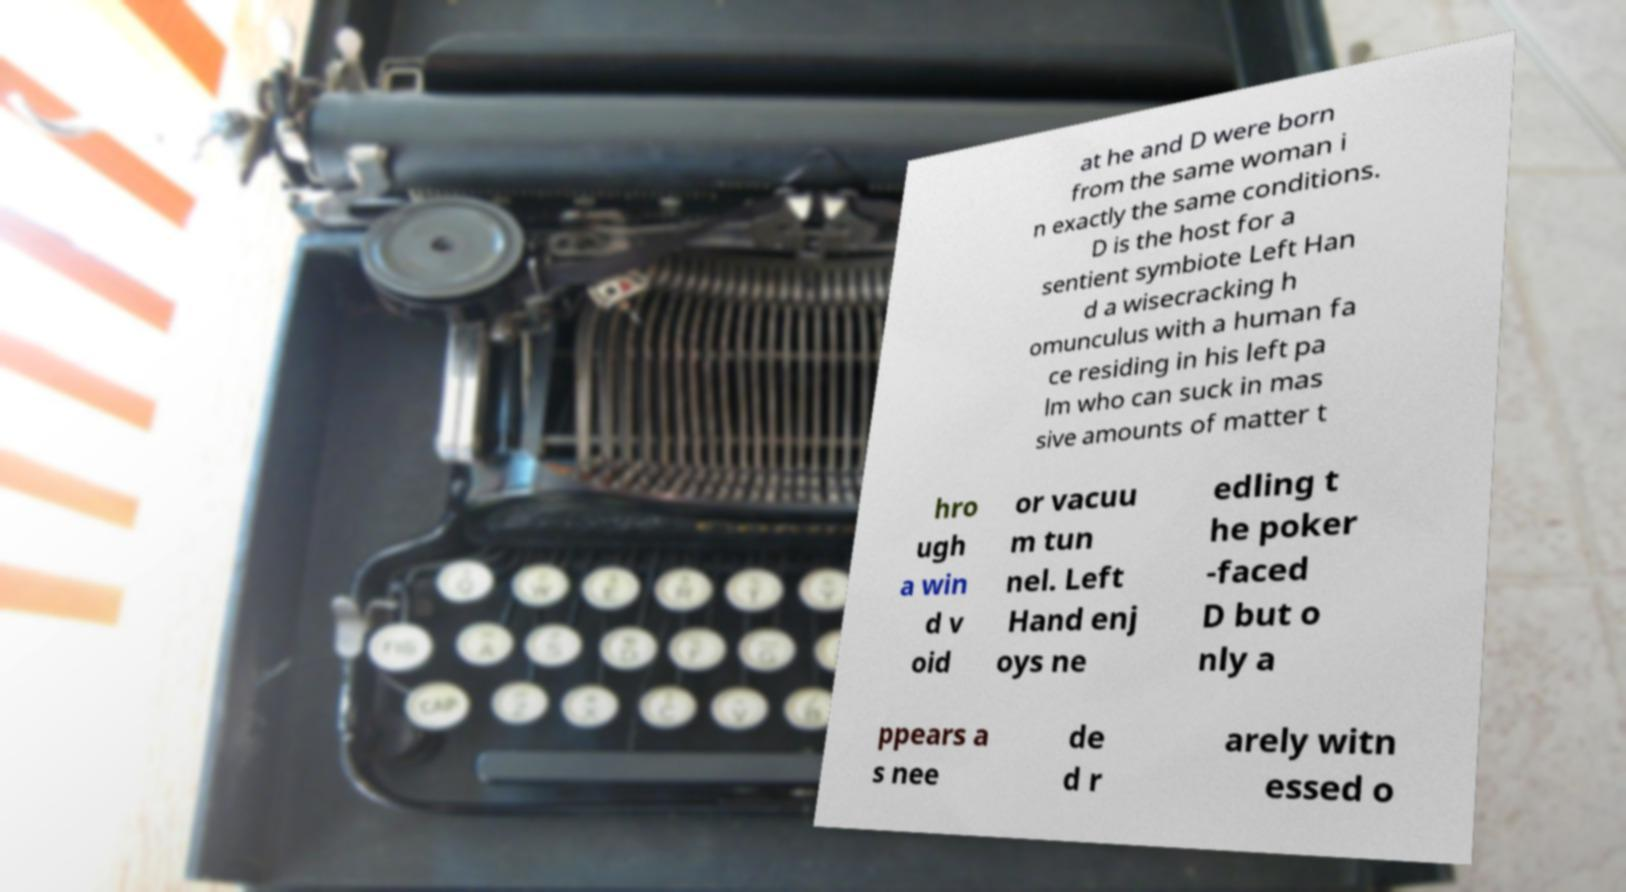Please read and relay the text visible in this image. What does it say? at he and D were born from the same woman i n exactly the same conditions. D is the host for a sentient symbiote Left Han d a wisecracking h omunculus with a human fa ce residing in his left pa lm who can suck in mas sive amounts of matter t hro ugh a win d v oid or vacuu m tun nel. Left Hand enj oys ne edling t he poker -faced D but o nly a ppears a s nee de d r arely witn essed o 